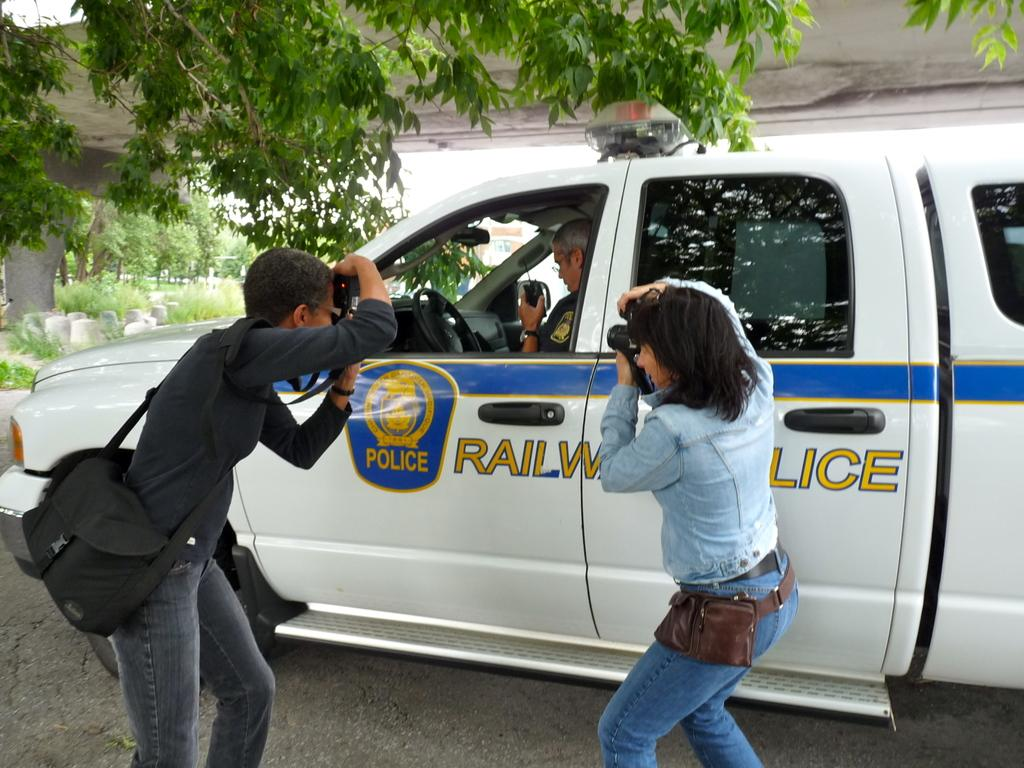How many people are in the image? There are two persons in the image. What are the two persons doing in the image? The two persons are holding a camera. Can you describe one of the persons in the image? One of the persons is a man. What is the man wearing in the image? The man is wearing a bag. What can be seen in the background of the image? There are trees in the background of the image. Can you describe the other person in the image? The other person is sitting in a car. What type of copper is being used to cook in the image? There is no copper or cooking activity present in the image. What is the name of the competition that the two persons are participating in? There is no competition mentioned or depicted in the image. 